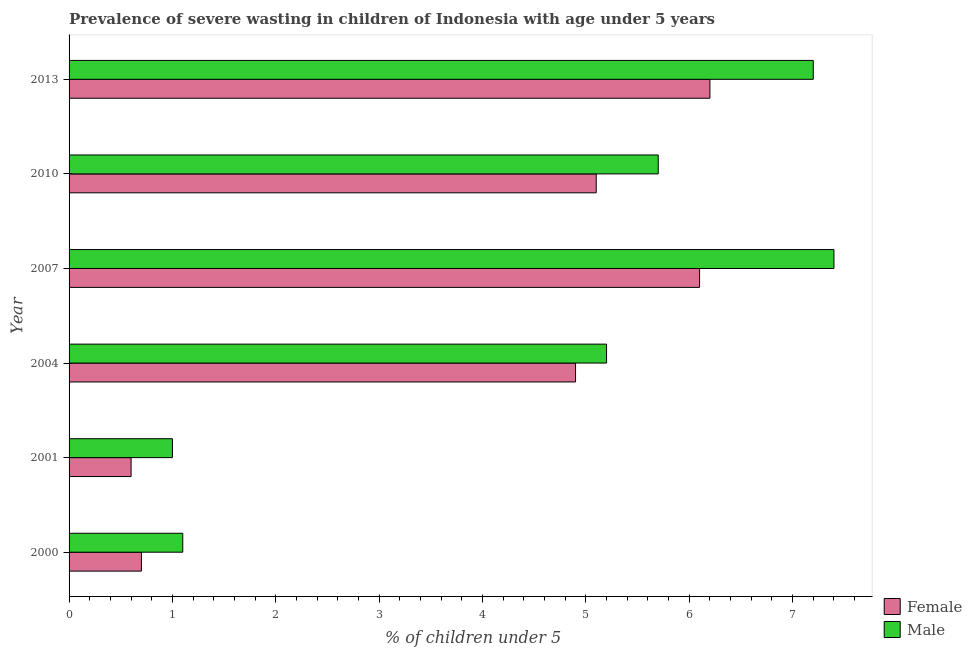How many different coloured bars are there?
Your answer should be compact. 2. How many groups of bars are there?
Offer a very short reply. 6. Are the number of bars per tick equal to the number of legend labels?
Your response must be concise. Yes. How many bars are there on the 2nd tick from the bottom?
Offer a very short reply. 2. What is the percentage of undernourished female children in 2004?
Ensure brevity in your answer.  4.9. Across all years, what is the maximum percentage of undernourished female children?
Ensure brevity in your answer.  6.2. Across all years, what is the minimum percentage of undernourished female children?
Your answer should be very brief. 0.6. What is the total percentage of undernourished male children in the graph?
Give a very brief answer. 27.6. What is the difference between the percentage of undernourished male children in 2001 and that in 2010?
Your answer should be very brief. -4.7. What is the difference between the percentage of undernourished female children in 2007 and the percentage of undernourished male children in 2001?
Provide a short and direct response. 5.1. What is the average percentage of undernourished female children per year?
Give a very brief answer. 3.93. What is the ratio of the percentage of undernourished male children in 2001 to that in 2013?
Make the answer very short. 0.14. Is the percentage of undernourished male children in 2000 less than that in 2004?
Keep it short and to the point. Yes. Is the difference between the percentage of undernourished male children in 2007 and 2013 greater than the difference between the percentage of undernourished female children in 2007 and 2013?
Give a very brief answer. Yes. What is the difference between the highest and the lowest percentage of undernourished female children?
Ensure brevity in your answer.  5.6. Is the sum of the percentage of undernourished female children in 2001 and 2010 greater than the maximum percentage of undernourished male children across all years?
Offer a terse response. No. What does the 2nd bar from the top in 2007 represents?
Your response must be concise. Female. How many bars are there?
Offer a terse response. 12. Are all the bars in the graph horizontal?
Your answer should be compact. Yes. What is the difference between two consecutive major ticks on the X-axis?
Give a very brief answer. 1. Are the values on the major ticks of X-axis written in scientific E-notation?
Provide a short and direct response. No. What is the title of the graph?
Keep it short and to the point. Prevalence of severe wasting in children of Indonesia with age under 5 years. What is the label or title of the X-axis?
Your answer should be compact.  % of children under 5. What is the  % of children under 5 of Female in 2000?
Give a very brief answer. 0.7. What is the  % of children under 5 of Male in 2000?
Your answer should be compact. 1.1. What is the  % of children under 5 in Female in 2001?
Offer a terse response. 0.6. What is the  % of children under 5 in Male in 2001?
Provide a short and direct response. 1. What is the  % of children under 5 of Female in 2004?
Your answer should be compact. 4.9. What is the  % of children under 5 of Male in 2004?
Provide a succinct answer. 5.2. What is the  % of children under 5 in Female in 2007?
Keep it short and to the point. 6.1. What is the  % of children under 5 of Male in 2007?
Offer a very short reply. 7.4. What is the  % of children under 5 of Female in 2010?
Give a very brief answer. 5.1. What is the  % of children under 5 of Male in 2010?
Provide a succinct answer. 5.7. What is the  % of children under 5 in Female in 2013?
Offer a very short reply. 6.2. What is the  % of children under 5 in Male in 2013?
Your answer should be compact. 7.2. Across all years, what is the maximum  % of children under 5 in Female?
Provide a succinct answer. 6.2. Across all years, what is the maximum  % of children under 5 of Male?
Your response must be concise. 7.4. Across all years, what is the minimum  % of children under 5 in Female?
Provide a short and direct response. 0.6. What is the total  % of children under 5 of Female in the graph?
Provide a succinct answer. 23.6. What is the total  % of children under 5 of Male in the graph?
Your response must be concise. 27.6. What is the difference between the  % of children under 5 of Female in 2000 and that in 2001?
Your answer should be very brief. 0.1. What is the difference between the  % of children under 5 in Male in 2000 and that in 2001?
Your response must be concise. 0.1. What is the difference between the  % of children under 5 of Female in 2000 and that in 2007?
Keep it short and to the point. -5.4. What is the difference between the  % of children under 5 of Male in 2000 and that in 2013?
Give a very brief answer. -6.1. What is the difference between the  % of children under 5 of Female in 2001 and that in 2004?
Give a very brief answer. -4.3. What is the difference between the  % of children under 5 of Male in 2001 and that in 2004?
Your response must be concise. -4.2. What is the difference between the  % of children under 5 of Female in 2001 and that in 2007?
Offer a terse response. -5.5. What is the difference between the  % of children under 5 in Male in 2001 and that in 2007?
Offer a very short reply. -6.4. What is the difference between the  % of children under 5 in Female in 2001 and that in 2010?
Ensure brevity in your answer.  -4.5. What is the difference between the  % of children under 5 of Female in 2001 and that in 2013?
Offer a very short reply. -5.6. What is the difference between the  % of children under 5 of Female in 2004 and that in 2010?
Your answer should be very brief. -0.2. What is the difference between the  % of children under 5 of Male in 2004 and that in 2010?
Offer a terse response. -0.5. What is the difference between the  % of children under 5 of Female in 2004 and that in 2013?
Your answer should be very brief. -1.3. What is the difference between the  % of children under 5 in Male in 2004 and that in 2013?
Make the answer very short. -2. What is the difference between the  % of children under 5 in Female in 2010 and that in 2013?
Give a very brief answer. -1.1. What is the difference between the  % of children under 5 of Male in 2010 and that in 2013?
Offer a terse response. -1.5. What is the difference between the  % of children under 5 of Female in 2000 and the  % of children under 5 of Male in 2001?
Give a very brief answer. -0.3. What is the difference between the  % of children under 5 in Female in 2000 and the  % of children under 5 in Male in 2004?
Your answer should be very brief. -4.5. What is the difference between the  % of children under 5 of Female in 2001 and the  % of children under 5 of Male in 2004?
Offer a very short reply. -4.6. What is the difference between the  % of children under 5 of Female in 2001 and the  % of children under 5 of Male in 2010?
Ensure brevity in your answer.  -5.1. What is the difference between the  % of children under 5 of Female in 2004 and the  % of children under 5 of Male in 2010?
Your answer should be very brief. -0.8. What is the difference between the  % of children under 5 in Female in 2004 and the  % of children under 5 in Male in 2013?
Your answer should be very brief. -2.3. What is the difference between the  % of children under 5 of Female in 2007 and the  % of children under 5 of Male in 2010?
Offer a very short reply. 0.4. What is the difference between the  % of children under 5 of Female in 2007 and the  % of children under 5 of Male in 2013?
Your answer should be very brief. -1.1. What is the difference between the  % of children under 5 of Female in 2010 and the  % of children under 5 of Male in 2013?
Make the answer very short. -2.1. What is the average  % of children under 5 of Female per year?
Keep it short and to the point. 3.93. In the year 2000, what is the difference between the  % of children under 5 of Female and  % of children under 5 of Male?
Ensure brevity in your answer.  -0.4. In the year 2007, what is the difference between the  % of children under 5 of Female and  % of children under 5 of Male?
Make the answer very short. -1.3. In the year 2010, what is the difference between the  % of children under 5 of Female and  % of children under 5 of Male?
Keep it short and to the point. -0.6. In the year 2013, what is the difference between the  % of children under 5 of Female and  % of children under 5 of Male?
Give a very brief answer. -1. What is the ratio of the  % of children under 5 in Female in 2000 to that in 2001?
Your answer should be very brief. 1.17. What is the ratio of the  % of children under 5 in Male in 2000 to that in 2001?
Make the answer very short. 1.1. What is the ratio of the  % of children under 5 in Female in 2000 to that in 2004?
Keep it short and to the point. 0.14. What is the ratio of the  % of children under 5 of Male in 2000 to that in 2004?
Offer a terse response. 0.21. What is the ratio of the  % of children under 5 of Female in 2000 to that in 2007?
Your answer should be compact. 0.11. What is the ratio of the  % of children under 5 in Male in 2000 to that in 2007?
Provide a succinct answer. 0.15. What is the ratio of the  % of children under 5 of Female in 2000 to that in 2010?
Provide a succinct answer. 0.14. What is the ratio of the  % of children under 5 of Male in 2000 to that in 2010?
Offer a very short reply. 0.19. What is the ratio of the  % of children under 5 of Female in 2000 to that in 2013?
Keep it short and to the point. 0.11. What is the ratio of the  % of children under 5 in Male in 2000 to that in 2013?
Give a very brief answer. 0.15. What is the ratio of the  % of children under 5 in Female in 2001 to that in 2004?
Make the answer very short. 0.12. What is the ratio of the  % of children under 5 of Male in 2001 to that in 2004?
Give a very brief answer. 0.19. What is the ratio of the  % of children under 5 of Female in 2001 to that in 2007?
Keep it short and to the point. 0.1. What is the ratio of the  % of children under 5 of Male in 2001 to that in 2007?
Your answer should be very brief. 0.14. What is the ratio of the  % of children under 5 of Female in 2001 to that in 2010?
Ensure brevity in your answer.  0.12. What is the ratio of the  % of children under 5 of Male in 2001 to that in 2010?
Your answer should be very brief. 0.18. What is the ratio of the  % of children under 5 of Female in 2001 to that in 2013?
Your response must be concise. 0.1. What is the ratio of the  % of children under 5 in Male in 2001 to that in 2013?
Your answer should be compact. 0.14. What is the ratio of the  % of children under 5 of Female in 2004 to that in 2007?
Offer a very short reply. 0.8. What is the ratio of the  % of children under 5 of Male in 2004 to that in 2007?
Ensure brevity in your answer.  0.7. What is the ratio of the  % of children under 5 of Female in 2004 to that in 2010?
Offer a very short reply. 0.96. What is the ratio of the  % of children under 5 in Male in 2004 to that in 2010?
Offer a terse response. 0.91. What is the ratio of the  % of children under 5 in Female in 2004 to that in 2013?
Provide a succinct answer. 0.79. What is the ratio of the  % of children under 5 in Male in 2004 to that in 2013?
Keep it short and to the point. 0.72. What is the ratio of the  % of children under 5 in Female in 2007 to that in 2010?
Give a very brief answer. 1.2. What is the ratio of the  % of children under 5 in Male in 2007 to that in 2010?
Your answer should be very brief. 1.3. What is the ratio of the  % of children under 5 of Female in 2007 to that in 2013?
Keep it short and to the point. 0.98. What is the ratio of the  % of children under 5 of Male in 2007 to that in 2013?
Give a very brief answer. 1.03. What is the ratio of the  % of children under 5 in Female in 2010 to that in 2013?
Offer a terse response. 0.82. What is the ratio of the  % of children under 5 in Male in 2010 to that in 2013?
Provide a short and direct response. 0.79. What is the difference between the highest and the second highest  % of children under 5 in Male?
Ensure brevity in your answer.  0.2. 